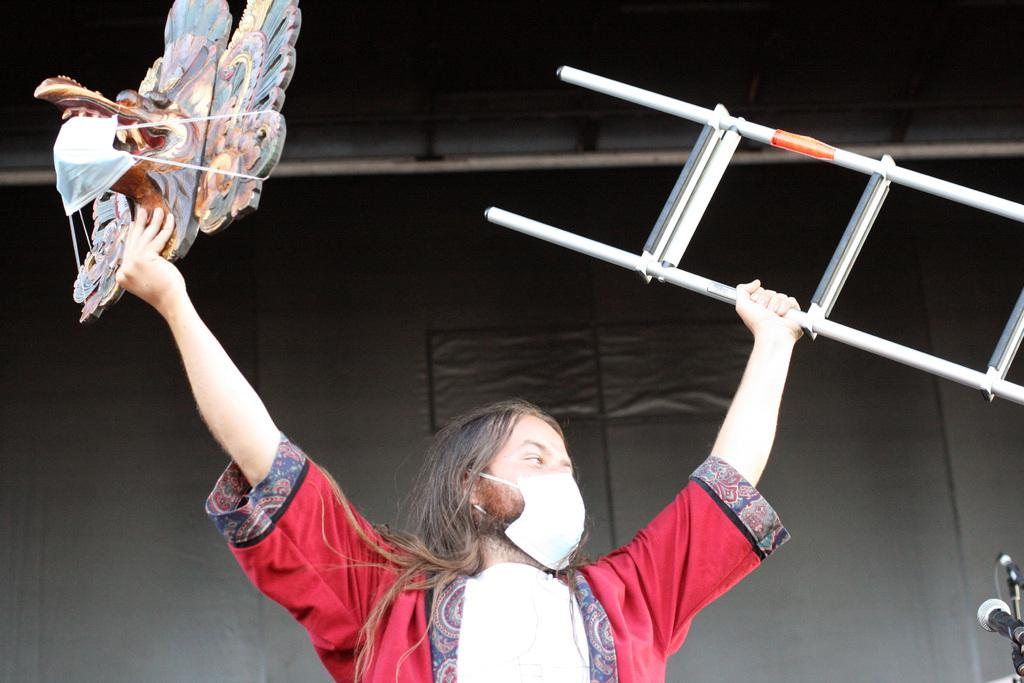What color is the jacket that the person in the image is wearing? The person in the image is wearing a red jacket. What type of protective gear is the person wearing? The person is wearing a mask around their mouth. What is the person doing with their hands in the image? The person is lifting an object with their hands. Can you see a kitten playing with a school in the image? There is no kitten or school present in the image. What type of object is the person shaking in the image? The person is not shaking any object in the image; they are lifting an object with their hands. 